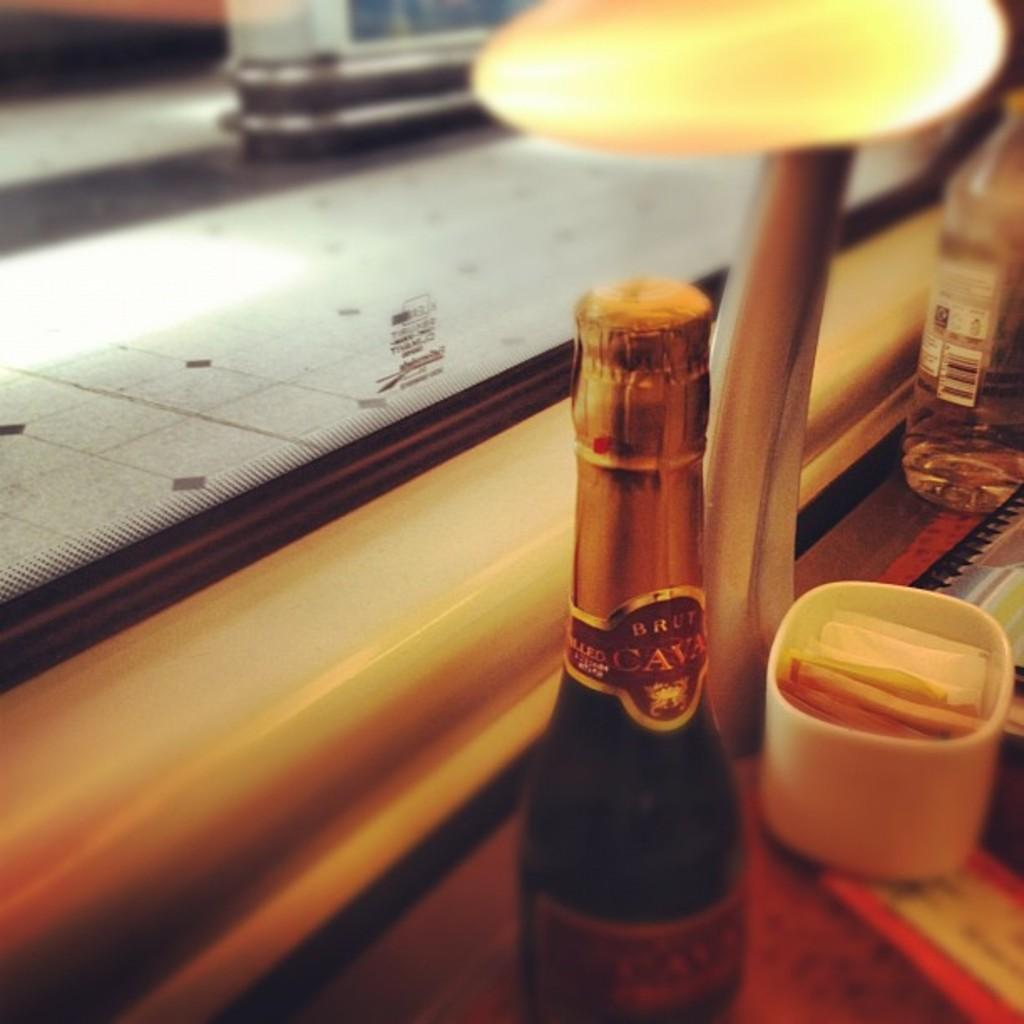<image>
Give a short and clear explanation of the subsequent image. A small bottle of wine says CAVA on the foil wrapper around the neck. 